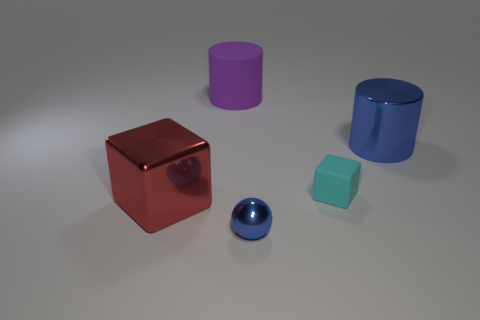Add 2 cyan matte objects. How many objects exist? 7 Subtract all balls. How many objects are left? 4 Add 4 cylinders. How many cylinders are left? 6 Add 2 small green cubes. How many small green cubes exist? 2 Subtract 0 green cylinders. How many objects are left? 5 Subtract all cyan metal blocks. Subtract all blue metal things. How many objects are left? 3 